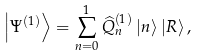Convert formula to latex. <formula><loc_0><loc_0><loc_500><loc_500>\left | \Psi ^ { ( 1 ) } \right \rangle = \sum _ { n = 0 } ^ { 1 } \widehat { Q } _ { n } ^ { ( 1 ) } \left | n \right \rangle \left | R \right \rangle ,</formula> 